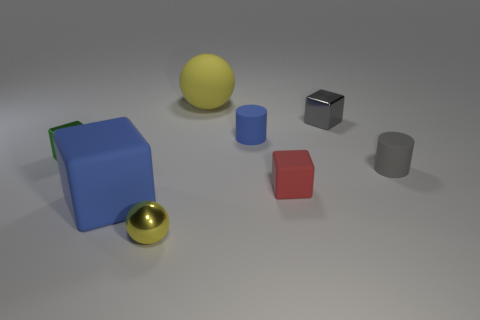Subtract all cyan blocks. Subtract all red balls. How many blocks are left? 4 Add 1 big yellow matte objects. How many objects exist? 9 Subtract all cylinders. How many objects are left? 6 Add 1 gray shiny blocks. How many gray shiny blocks exist? 2 Subtract 0 cyan blocks. How many objects are left? 8 Subtract all tiny red metallic spheres. Subtract all tiny shiny cubes. How many objects are left? 6 Add 2 tiny blue objects. How many tiny blue objects are left? 3 